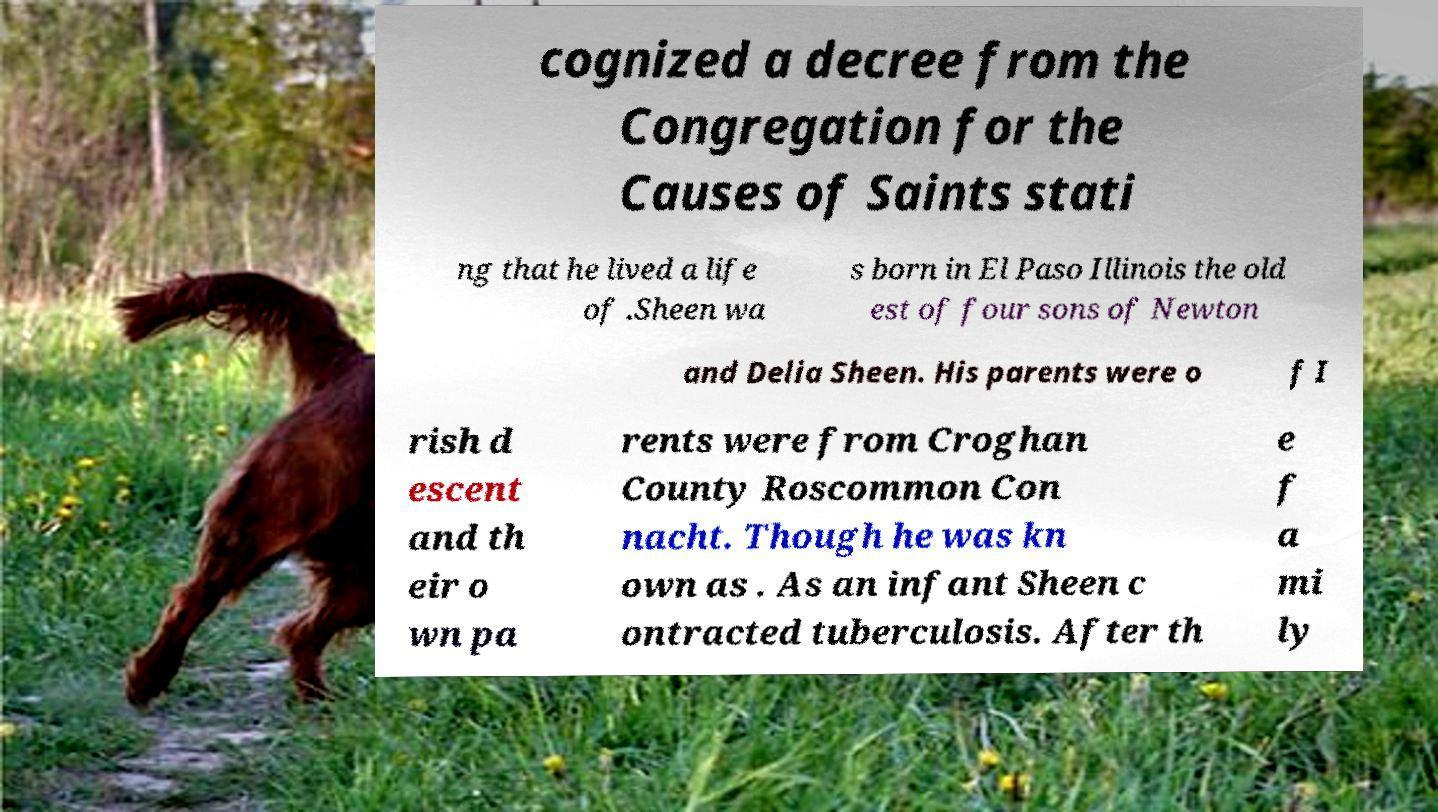Could you assist in decoding the text presented in this image and type it out clearly? cognized a decree from the Congregation for the Causes of Saints stati ng that he lived a life of .Sheen wa s born in El Paso Illinois the old est of four sons of Newton and Delia Sheen. His parents were o f I rish d escent and th eir o wn pa rents were from Croghan County Roscommon Con nacht. Though he was kn own as . As an infant Sheen c ontracted tuberculosis. After th e f a mi ly 